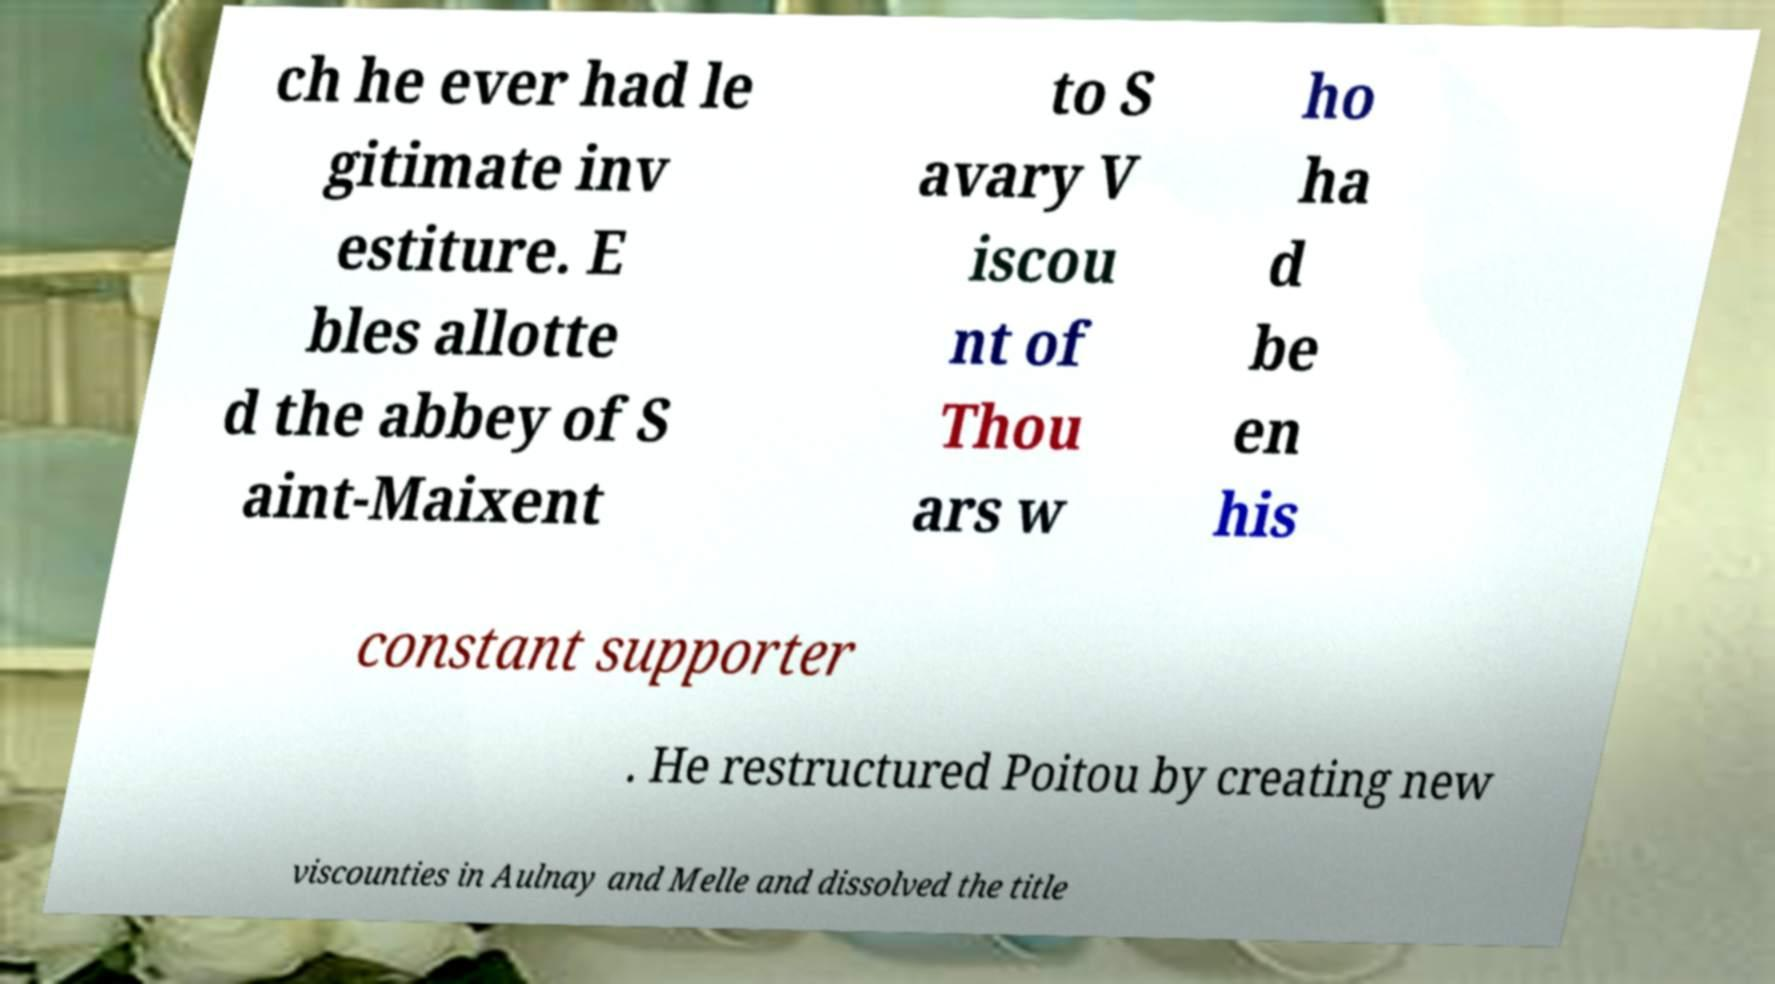Could you assist in decoding the text presented in this image and type it out clearly? ch he ever had le gitimate inv estiture. E bles allotte d the abbey of S aint-Maixent to S avary V iscou nt of Thou ars w ho ha d be en his constant supporter . He restructured Poitou by creating new viscounties in Aulnay and Melle and dissolved the title 